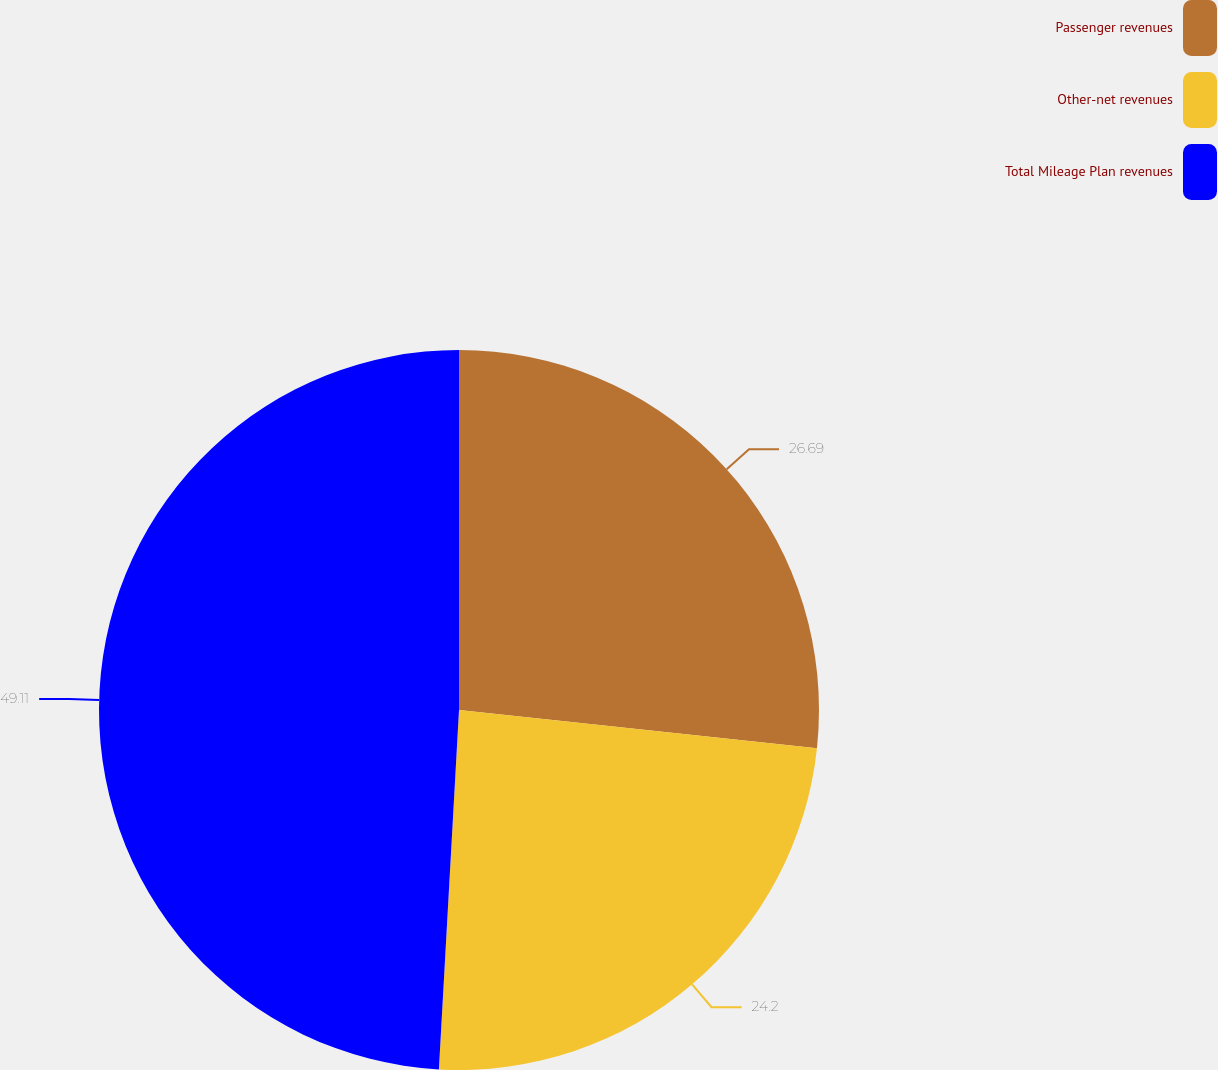Convert chart to OTSL. <chart><loc_0><loc_0><loc_500><loc_500><pie_chart><fcel>Passenger revenues<fcel>Other-net revenues<fcel>Total Mileage Plan revenues<nl><fcel>26.69%<fcel>24.2%<fcel>49.11%<nl></chart> 